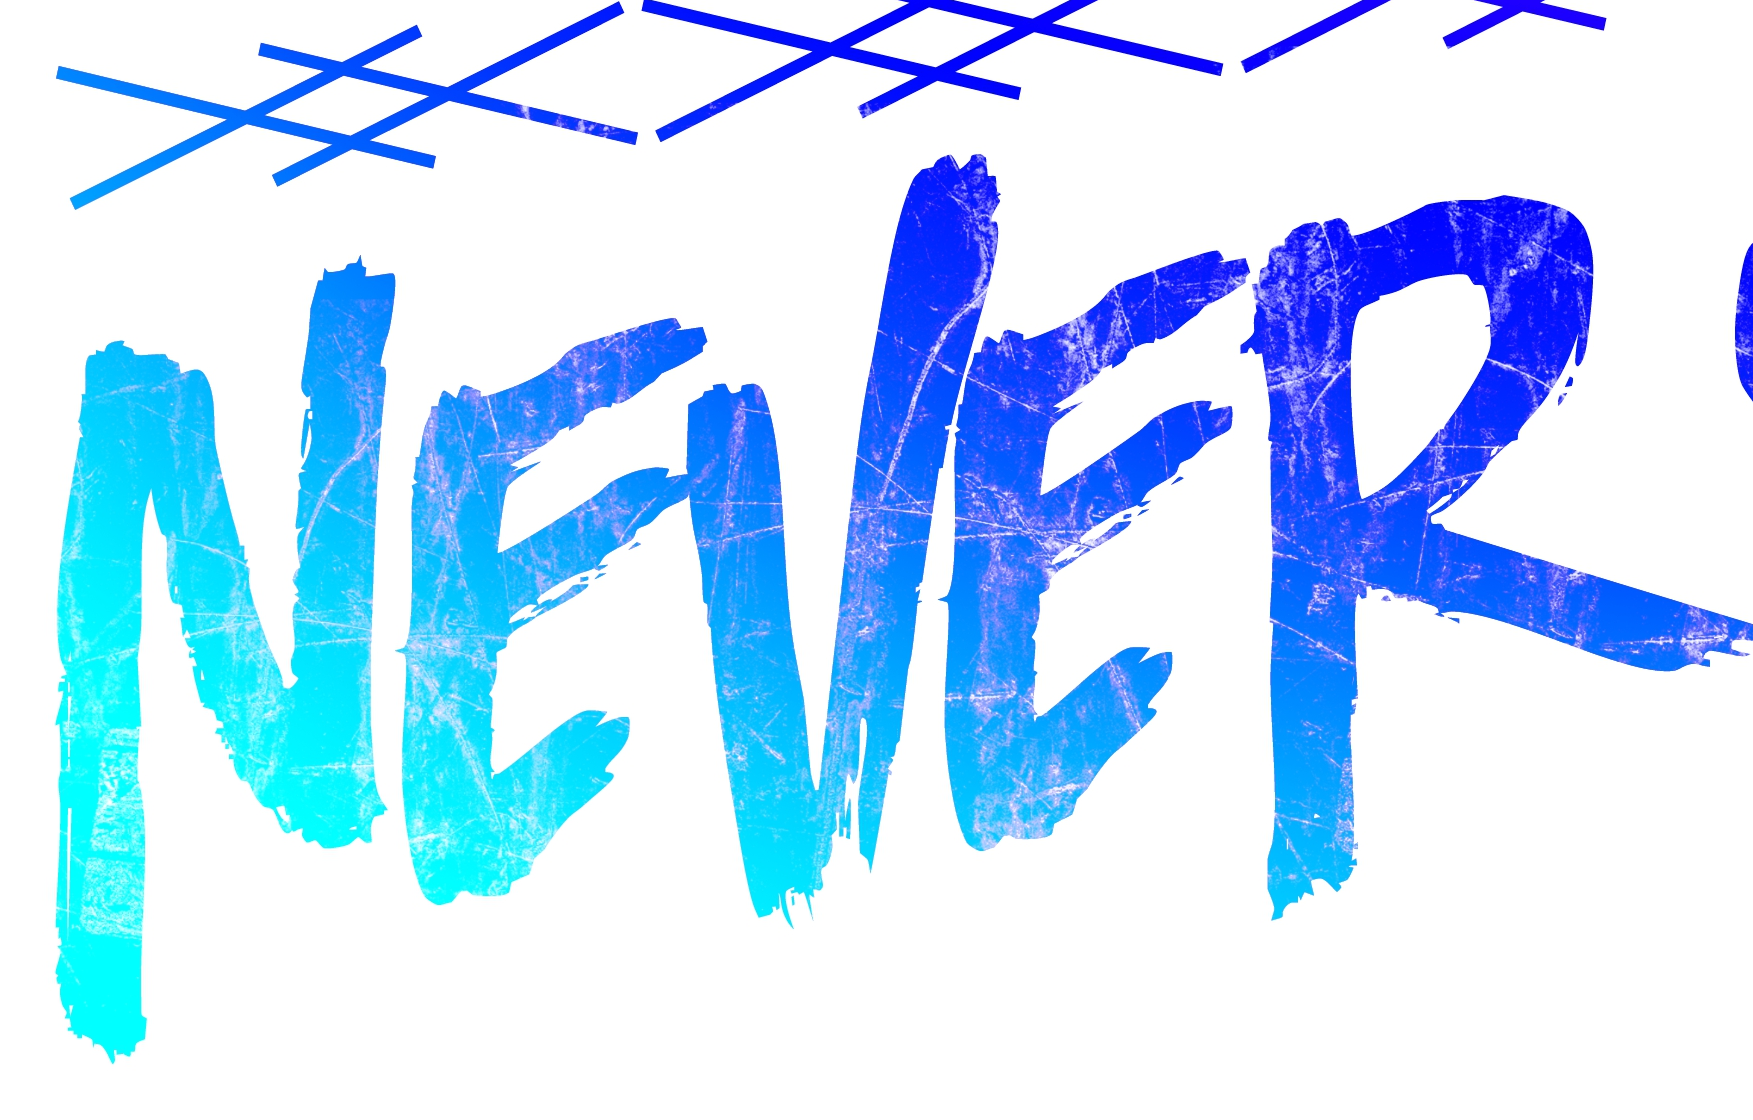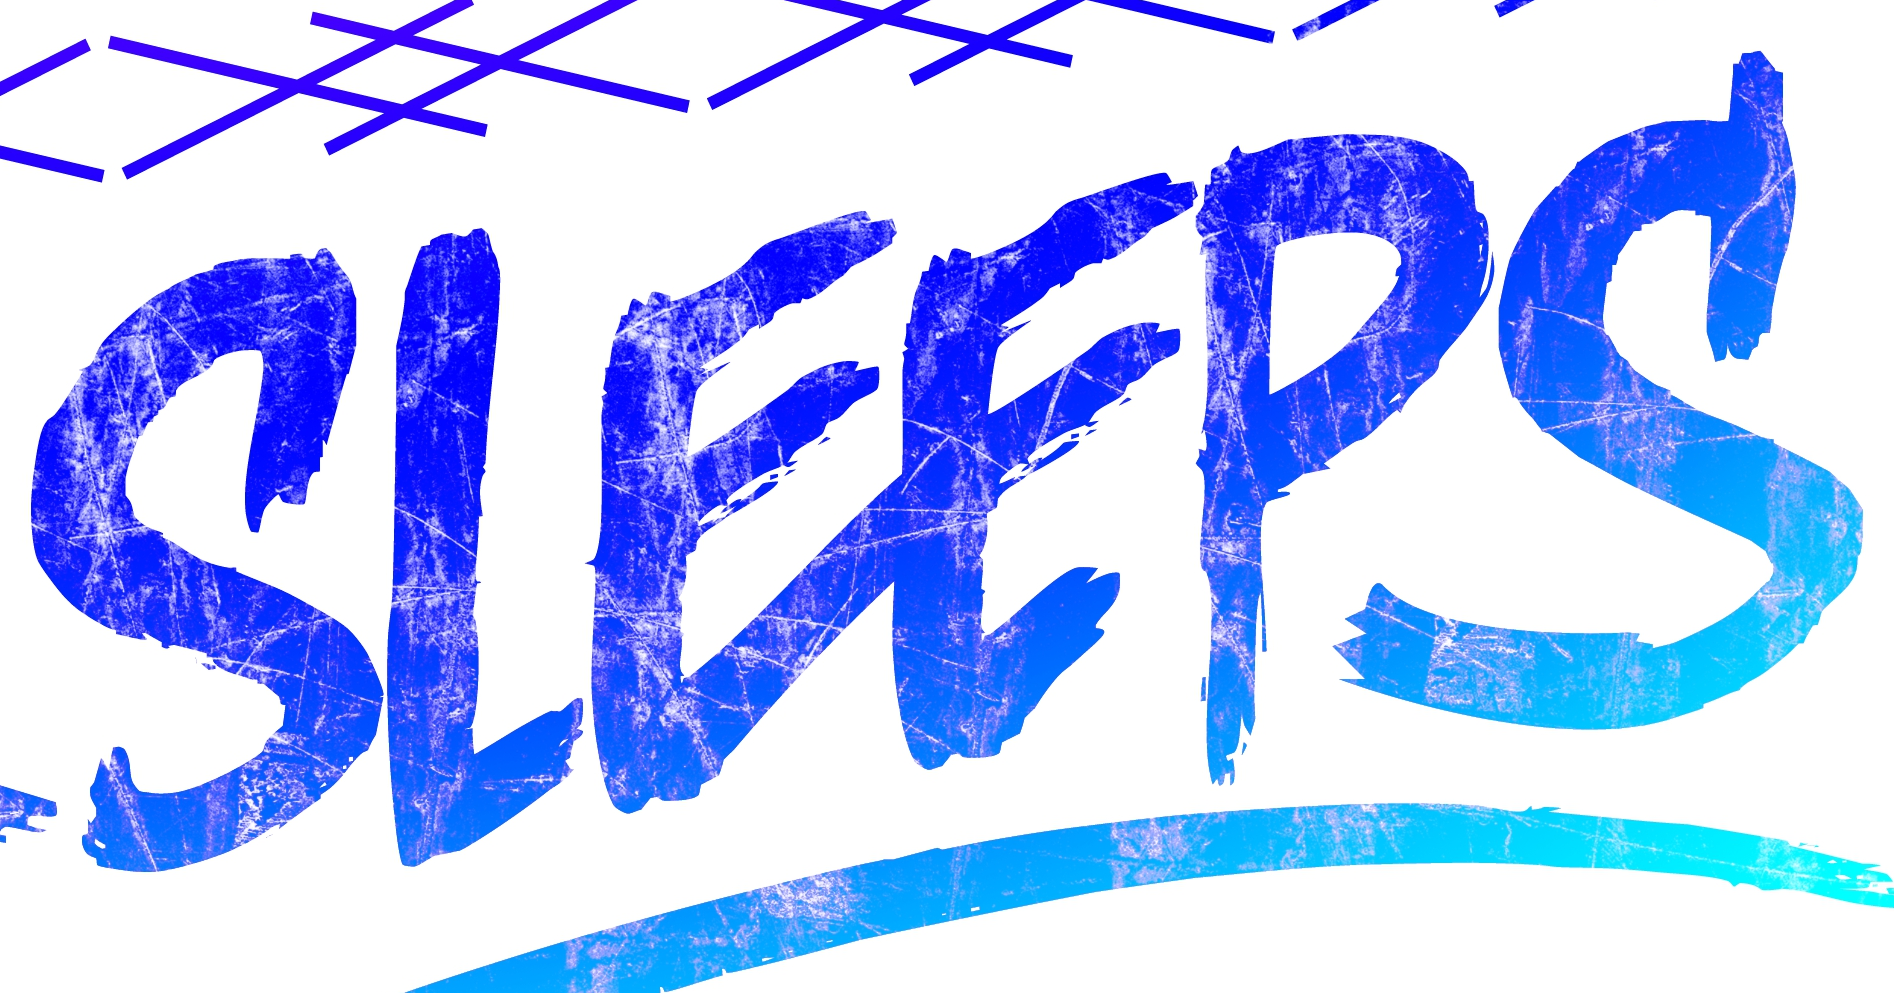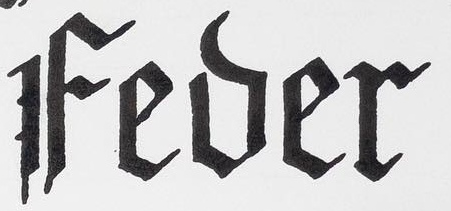Transcribe the words shown in these images in order, separated by a semicolon. NEVER; SLEEPS; Fever 